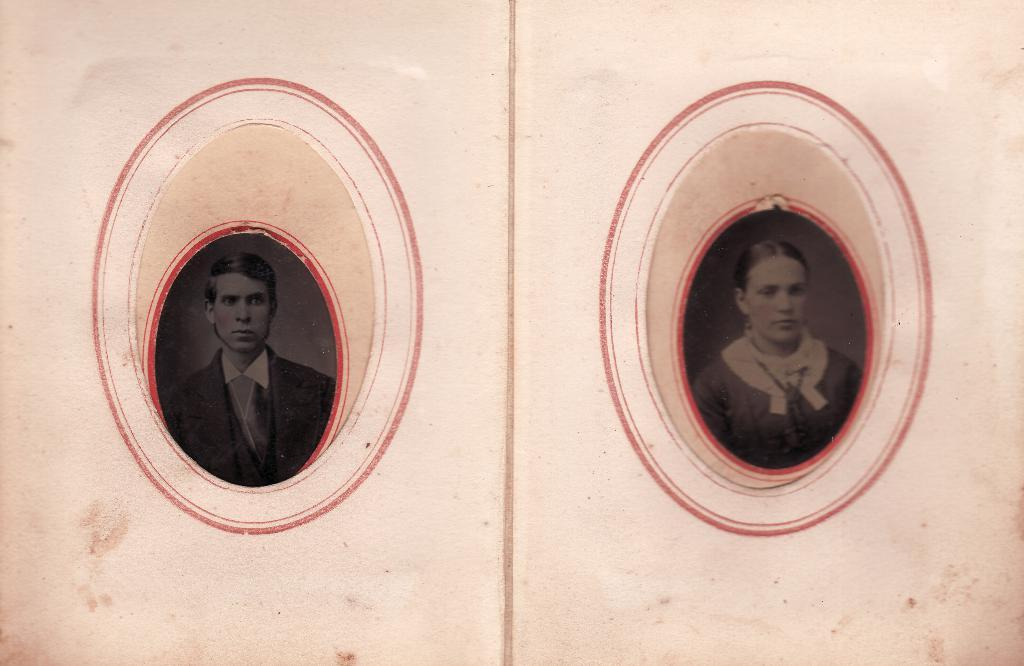What is depicted on the left side of the image? There is a picture of a man on the left side of the image. What is depicted on the right side of the image? There is a picture of a woman on the right side of the image. Can you tell me how many kitties are visible in the image? There are no kitties present in the image; it only features pictures of a man and a woman. What is the digestion process of the man in the image? There is no information about the man's digestion process in the image, as it only shows a picture of him. 